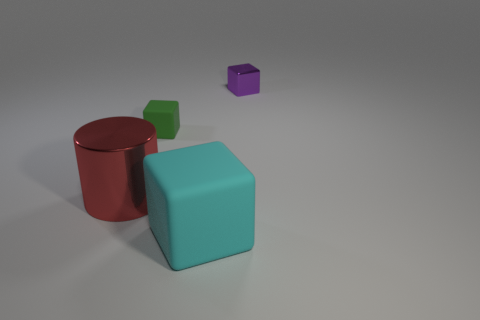What is the color of the other shiny thing that is the same shape as the green object?
Make the answer very short. Purple. Is there any other thing that is the same color as the big metallic object?
Offer a terse response. No. How many matte objects are brown cylinders or purple cubes?
Keep it short and to the point. 0. Are there more red cylinders that are in front of the purple metal cube than cyan cylinders?
Give a very brief answer. Yes. How many other objects are the same material as the cylinder?
Offer a very short reply. 1. What number of big objects are cyan rubber cylinders or shiny objects?
Your response must be concise. 1. Do the large cube and the small green block have the same material?
Ensure brevity in your answer.  Yes. There is a big thing that is to the left of the big cyan object; what number of large cyan rubber blocks are behind it?
Keep it short and to the point. 0. Is there a large cyan thing that has the same shape as the tiny matte object?
Provide a succinct answer. Yes. There is a metallic thing to the right of the large red metal cylinder; does it have the same shape as the metallic object that is in front of the green matte object?
Your answer should be very brief. No. 